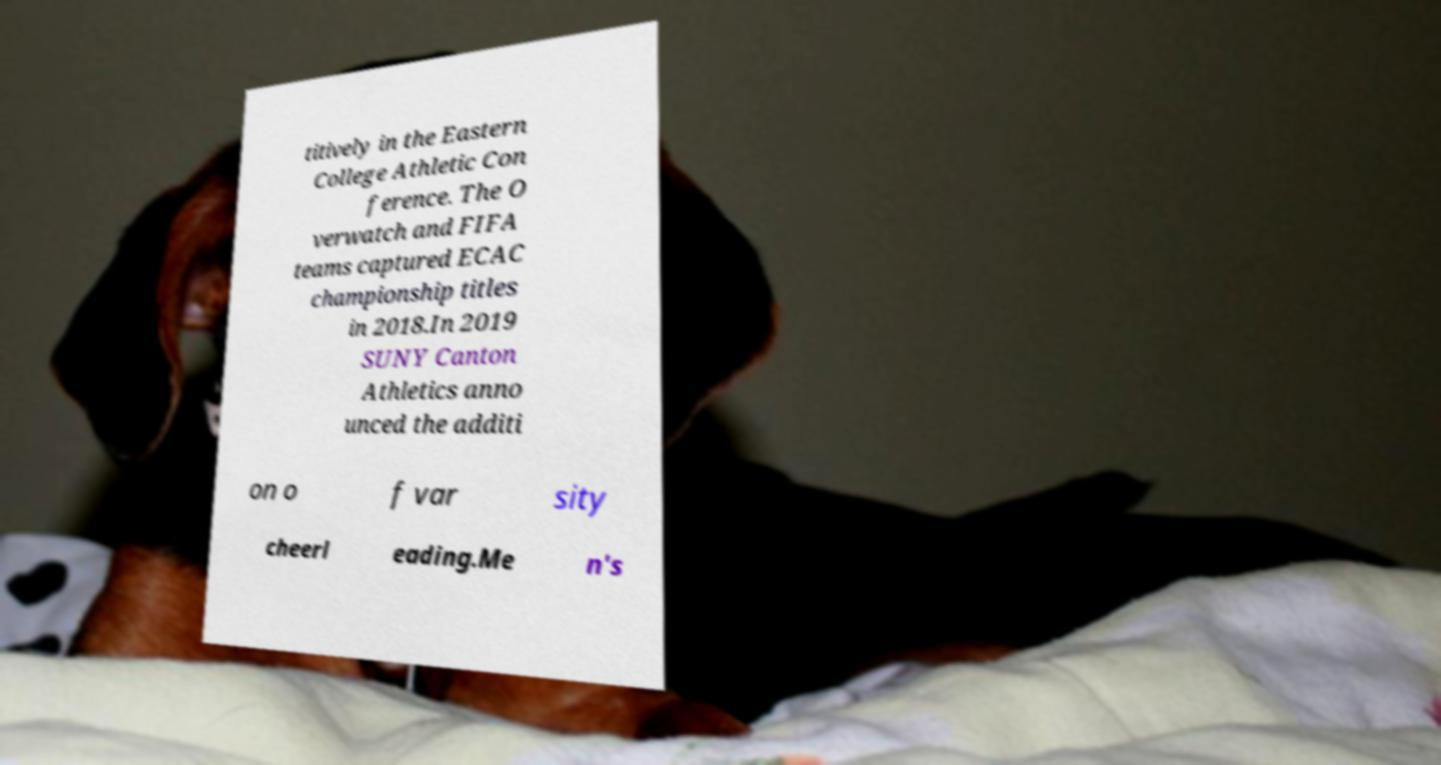Could you assist in decoding the text presented in this image and type it out clearly? titively in the Eastern College Athletic Con ference. The O verwatch and FIFA teams captured ECAC championship titles in 2018.In 2019 SUNY Canton Athletics anno unced the additi on o f var sity cheerl eading.Me n's 